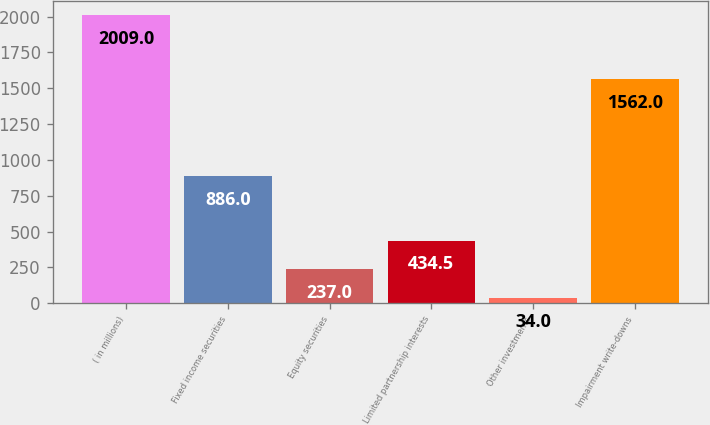<chart> <loc_0><loc_0><loc_500><loc_500><bar_chart><fcel>( in millions)<fcel>Fixed income securities<fcel>Equity securities<fcel>Limited partnership interests<fcel>Other investments<fcel>Impairment write-downs<nl><fcel>2009<fcel>886<fcel>237<fcel>434.5<fcel>34<fcel>1562<nl></chart> 